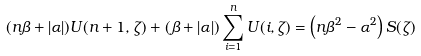<formula> <loc_0><loc_0><loc_500><loc_500>( n \beta + | \alpha | ) U ( n + 1 , \zeta ) + ( \beta + | \alpha | ) \sum _ { i = 1 } ^ { n } U ( i , \zeta ) = \left ( n \beta ^ { 2 } - \alpha ^ { 2 } \right ) S ( \zeta )</formula> 